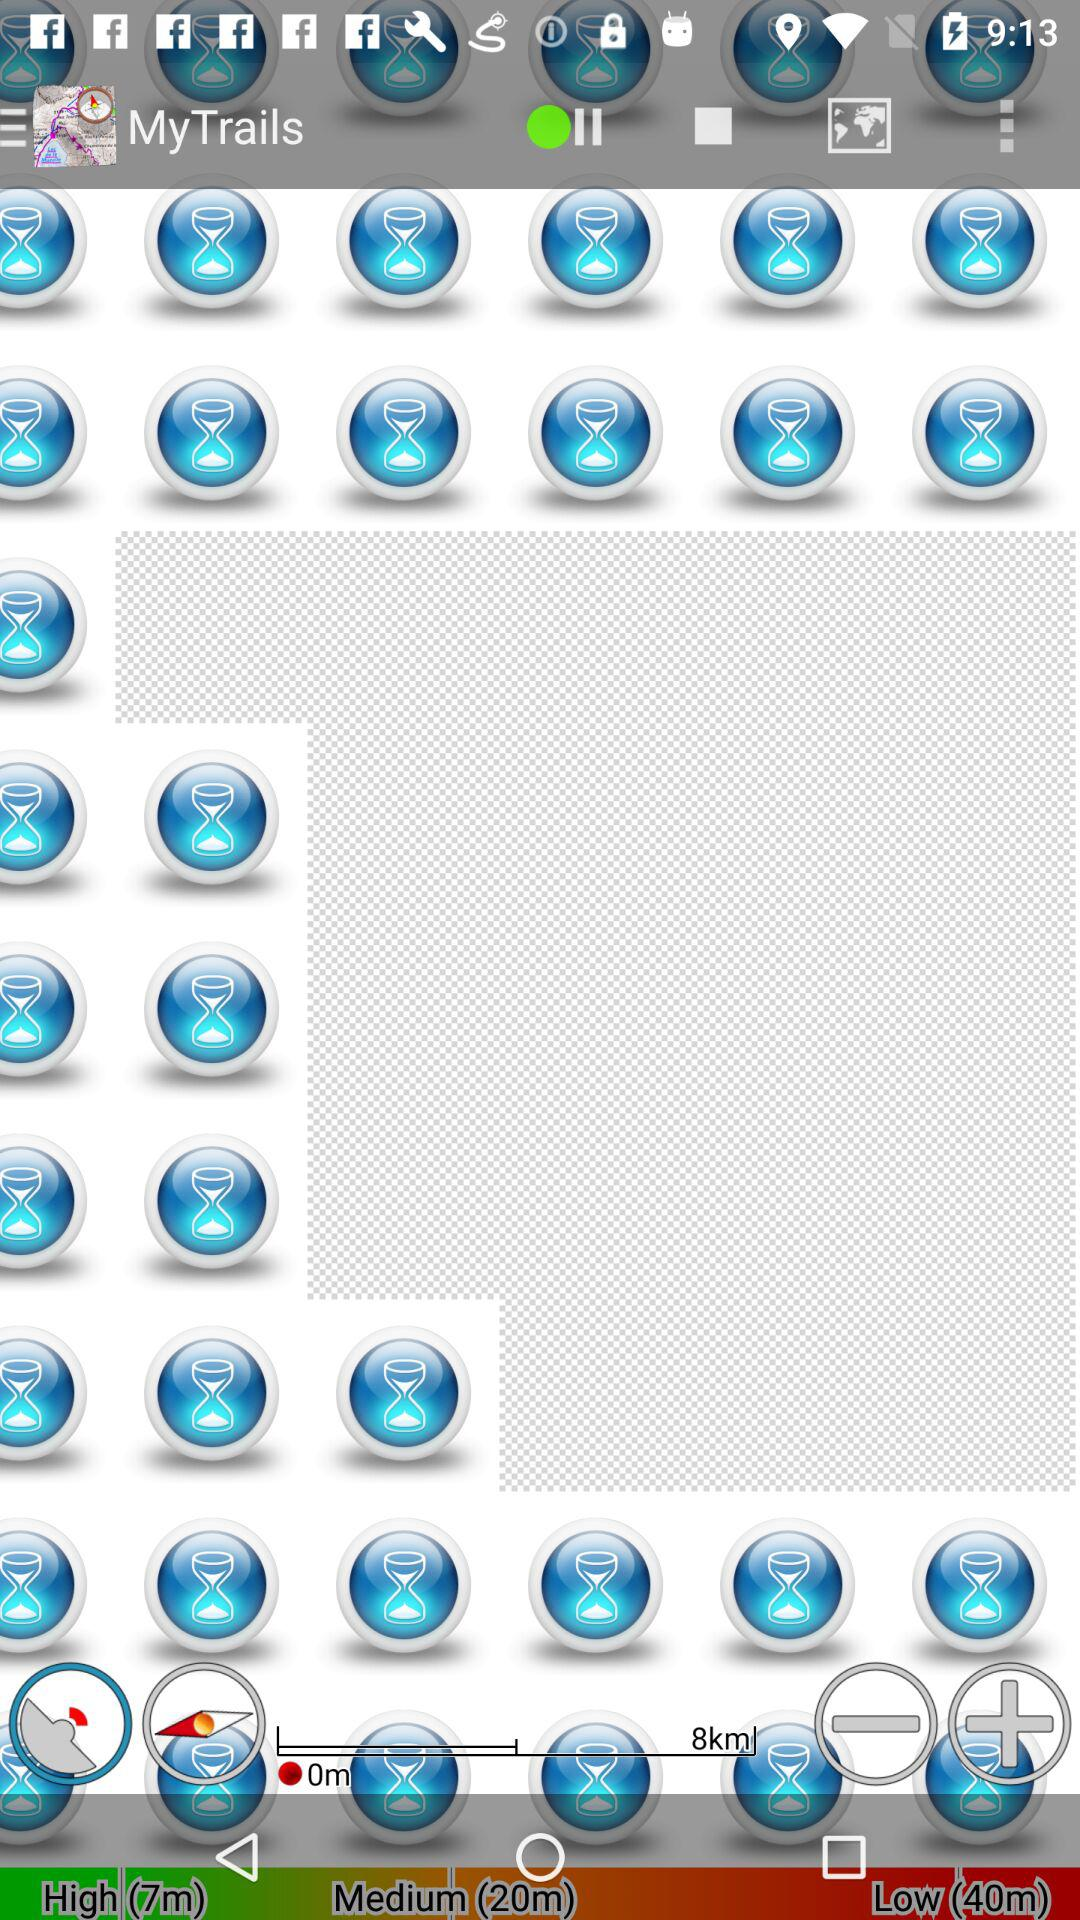What is the name of the application? The name of the application is "MyTrails". 